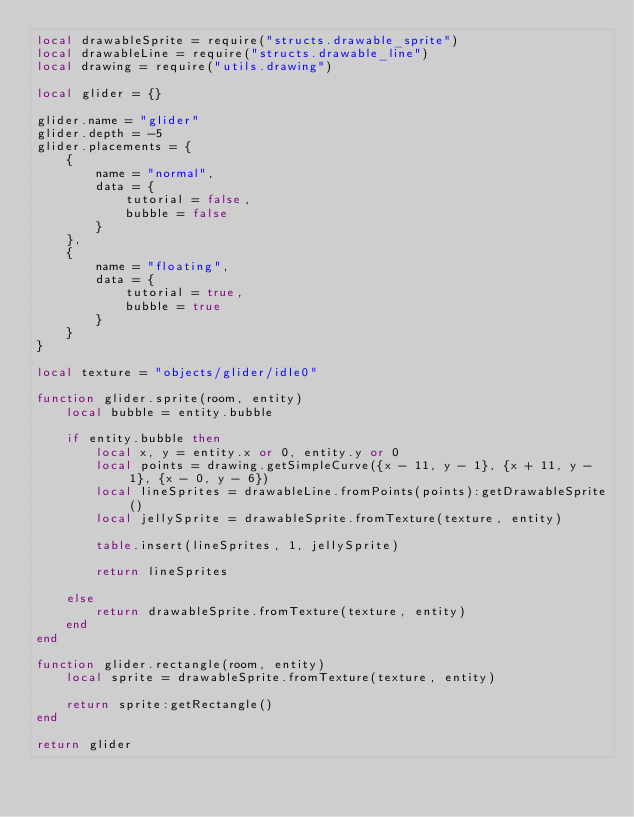<code> <loc_0><loc_0><loc_500><loc_500><_Lua_>local drawableSprite = require("structs.drawable_sprite")
local drawableLine = require("structs.drawable_line")
local drawing = require("utils.drawing")

local glider = {}

glider.name = "glider"
glider.depth = -5
glider.placements = {
    {
        name = "normal",
        data = {
            tutorial = false,
            bubble = false
        }
    },
    {
        name = "floating",
        data = {
            tutorial = true,
            bubble = true
        }
    }
}

local texture = "objects/glider/idle0"

function glider.sprite(room, entity)
    local bubble = entity.bubble

    if entity.bubble then
        local x, y = entity.x or 0, entity.y or 0
        local points = drawing.getSimpleCurve({x - 11, y - 1}, {x + 11, y - 1}, {x - 0, y - 6})
        local lineSprites = drawableLine.fromPoints(points):getDrawableSprite()
        local jellySprite = drawableSprite.fromTexture(texture, entity)

        table.insert(lineSprites, 1, jellySprite)

        return lineSprites

    else
        return drawableSprite.fromTexture(texture, entity)
    end
end

function glider.rectangle(room, entity)
    local sprite = drawableSprite.fromTexture(texture, entity)

    return sprite:getRectangle()
end

return glider</code> 